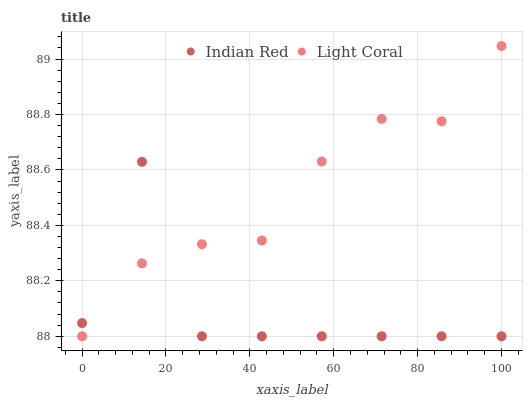Does Indian Red have the minimum area under the curve?
Answer yes or no. Yes. Does Light Coral have the maximum area under the curve?
Answer yes or no. Yes. Does Indian Red have the maximum area under the curve?
Answer yes or no. No. Is Light Coral the smoothest?
Answer yes or no. Yes. Is Indian Red the roughest?
Answer yes or no. Yes. Is Indian Red the smoothest?
Answer yes or no. No. Does Light Coral have the lowest value?
Answer yes or no. Yes. Does Light Coral have the highest value?
Answer yes or no. Yes. Does Indian Red have the highest value?
Answer yes or no. No. Does Light Coral intersect Indian Red?
Answer yes or no. Yes. Is Light Coral less than Indian Red?
Answer yes or no. No. Is Light Coral greater than Indian Red?
Answer yes or no. No. 